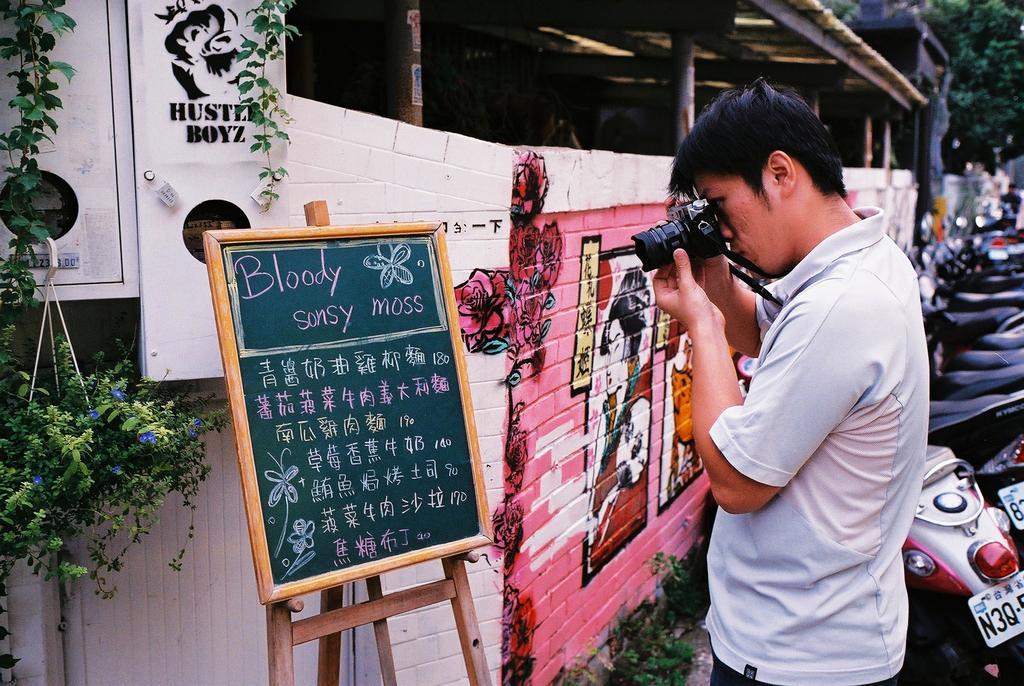Describe this image in one or two sentences. In this picture a guy is holding a camera and clicking pictures of the board present opposite to him which is named as bloody sunday moss. In the background we observe many plants , posters and a house. To the right side of the image there are vehicles placed. 